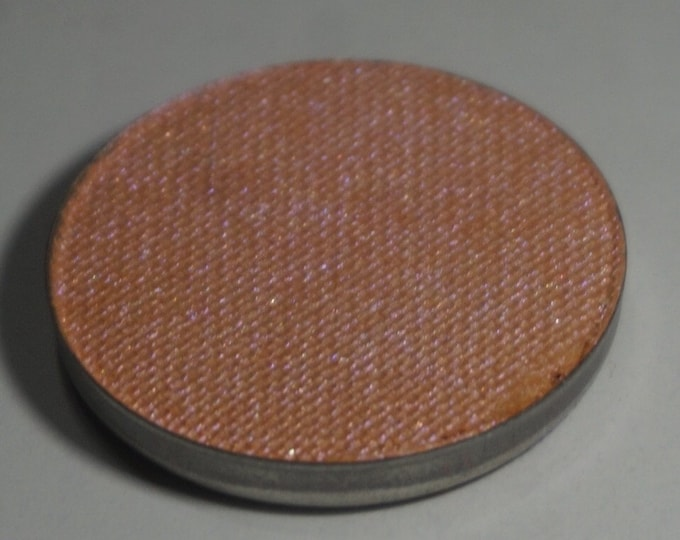Given the texture and appearance of the surface of the disc, what could be the potential use or function of this object? Based on the texture and appearance, the disc could be a cover for a speaker or part of an acoustic device. The fabric material and the textured weave pattern suggest it is designed to allow sound to pass through while protecting the internal components of a speaker. The rigid rim provides structural integrity and could be part of a mounting system to secure it in place. Additionally, this disc may serve a decorative purpose, effectively concealing the speaker components while seamlessly blending into the environment's aesthetic. The specific weave and material choice can also hint at a design aimed at reducing dust and other particulate infiltration, thereby extending the lifespan of the internal components. 